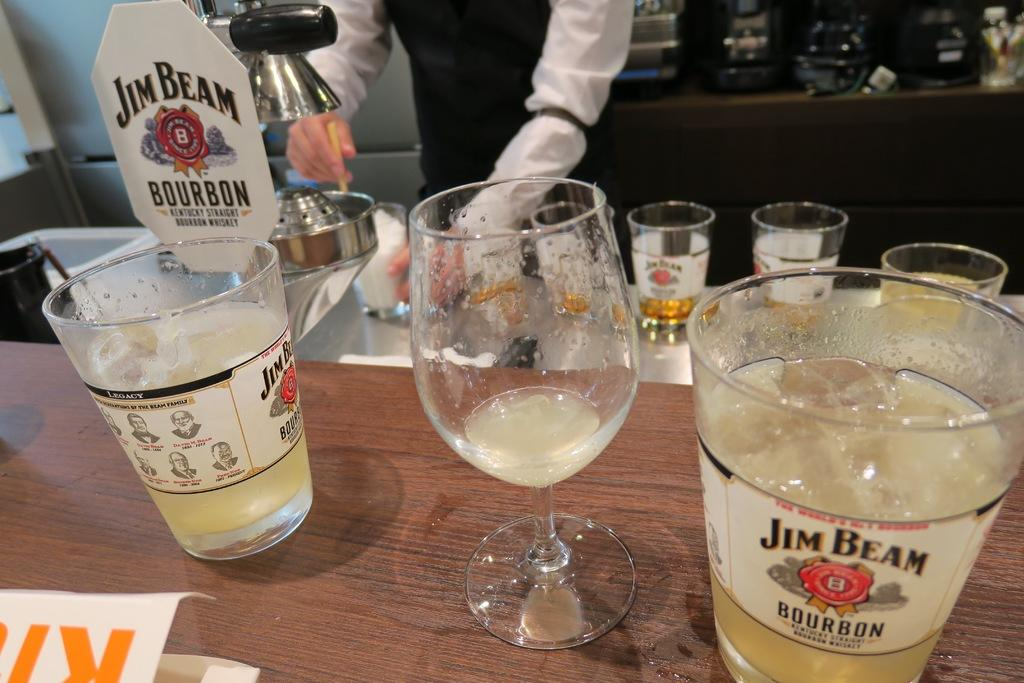What objects are on the table in the image? There are wine glasses on the table. What is the waiter doing in the image? The waiter is preparing wine from a silver machine. What can be seen on the waiter's shirt? The waiter is wearing a black and white shirt. What type of meat is being served by the waiter in the image? There is no meat present in the image; the waiter is preparing wine from a silver machine. What emotion does the waiter express towards the customers in the image? The image does not show any emotions expressed by the waiter, so it cannot be determined from the image. 